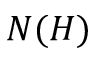<formula> <loc_0><loc_0><loc_500><loc_500>N ( H )</formula> 